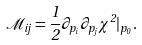Convert formula to latex. <formula><loc_0><loc_0><loc_500><loc_500>\mathcal { M } _ { i j } = { \frac { 1 } { 2 } } \partial _ { p _ { i } } \partial _ { p _ { j } } \chi ^ { 2 } | _ { p _ { 0 } } .</formula> 